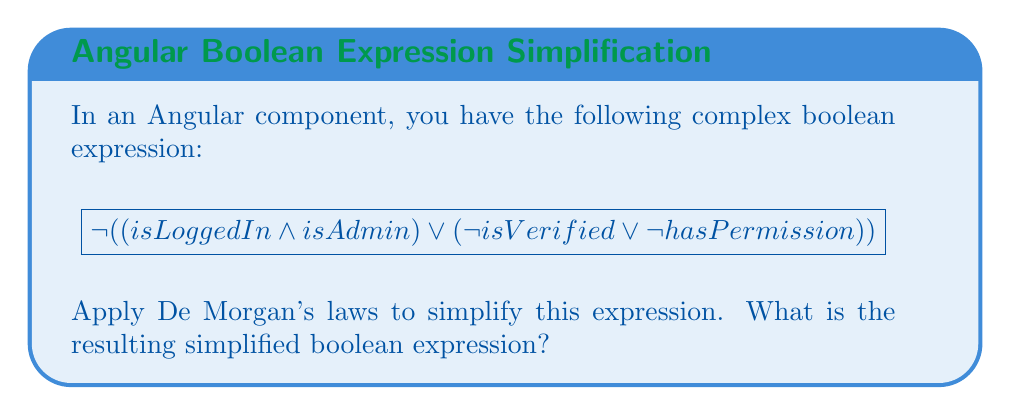Can you answer this question? Let's simplify this expression step by step using De Morgan's laws:

1. First, let's apply De Morgan's law to the outermost negation:
   $$ \neg((isLoggedIn \land isAdmin) \lor (\neg isVerified \lor \neg hasPermission)) $$
   becomes
   $$ \neg(isLoggedIn \land isAdmin) \land \neg(\neg isVerified \lor \neg hasPermission) $$

2. Now, let's apply De Morgan's law to each part:
   For $\neg(isLoggedIn \land isAdmin)$:
   $$ \neg isLoggedIn \lor \neg isAdmin $$

   For $\neg(\neg isVerified \lor \neg hasPermission)$:
   $$ \neg \neg isVerified \land \neg \neg hasPermission $$

3. Simplify the double negations:
   $$ \neg isLoggedIn \lor \neg isAdmin \land isVerified \land hasPermission $$

4. The final simplified expression is:
   $$ (\neg isLoggedIn \lor \neg isAdmin) \land isVerified \land hasPermission $$

This simplified expression can be directly used in Angular component logic, improving readability and potentially performance.
Answer: $(\neg isLoggedIn \lor \neg isAdmin) \land isVerified \land hasPermission$ 